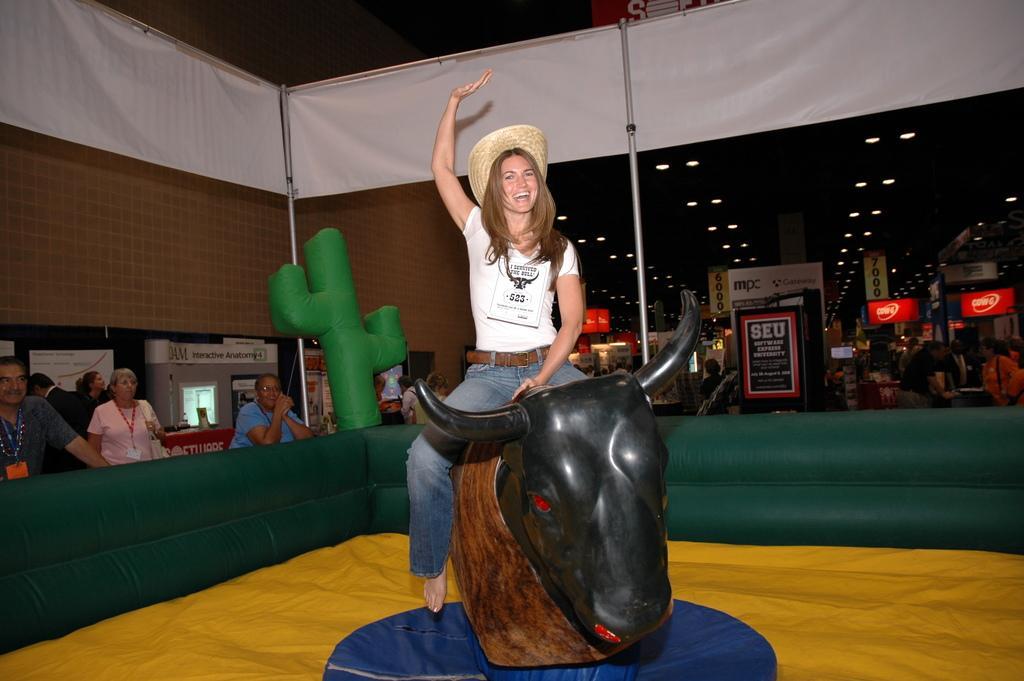Can you describe this image briefly? In this image we can see a woman wearing the hat and sitting on the horse sculpture and smiling. We can also see the people wearing the tags and standing. We can see the boards, banners, lights, ceiling, wall and also the rods. We can also see the yellow color cloth and also the green color barrier. 